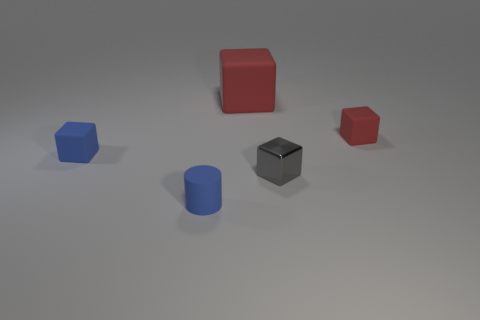Add 2 small gray metallic cubes. How many objects exist? 7 Subtract all blocks. How many objects are left? 1 Add 1 gray rubber objects. How many gray rubber objects exist? 1 Subtract 0 gray cylinders. How many objects are left? 5 Subtract all small objects. Subtract all big matte cylinders. How many objects are left? 1 Add 1 tiny gray cubes. How many tiny gray cubes are left? 2 